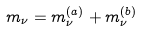<formula> <loc_0><loc_0><loc_500><loc_500>m _ { \nu } = m _ { \nu } ^ { ( a ) } + m _ { \nu } ^ { ( b ) }</formula> 